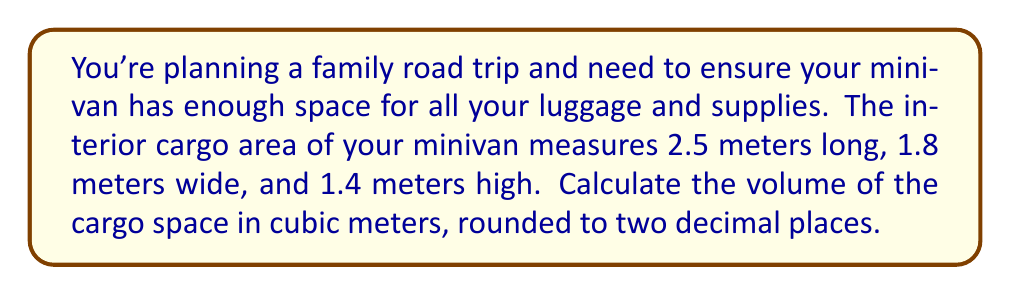Solve this math problem. To calculate the volume of the minivan's cargo space, we need to use the formula for the volume of a rectangular prism, as the cargo area is essentially a box-shaped space.

The formula for the volume of a rectangular prism is:

$$ V = l \times w \times h $$

Where:
$V$ = volume
$l$ = length
$w$ = width
$h$ = height

Given dimensions:
Length ($l$) = 2.5 meters
Width ($w$) = 1.8 meters
Height ($h$) = 1.4 meters

Let's substitute these values into the formula:

$$ V = 2.5 \text{ m} \times 1.8 \text{ m} \times 1.4 \text{ m} $$

Now, let's multiply these numbers:

$$ V = 6.3 \text{ m}^3 $$

The question asks for the answer rounded to two decimal places, but our result already has only one decimal place, so no further rounding is necessary.
Answer: $6.3 \text{ m}^3$ 